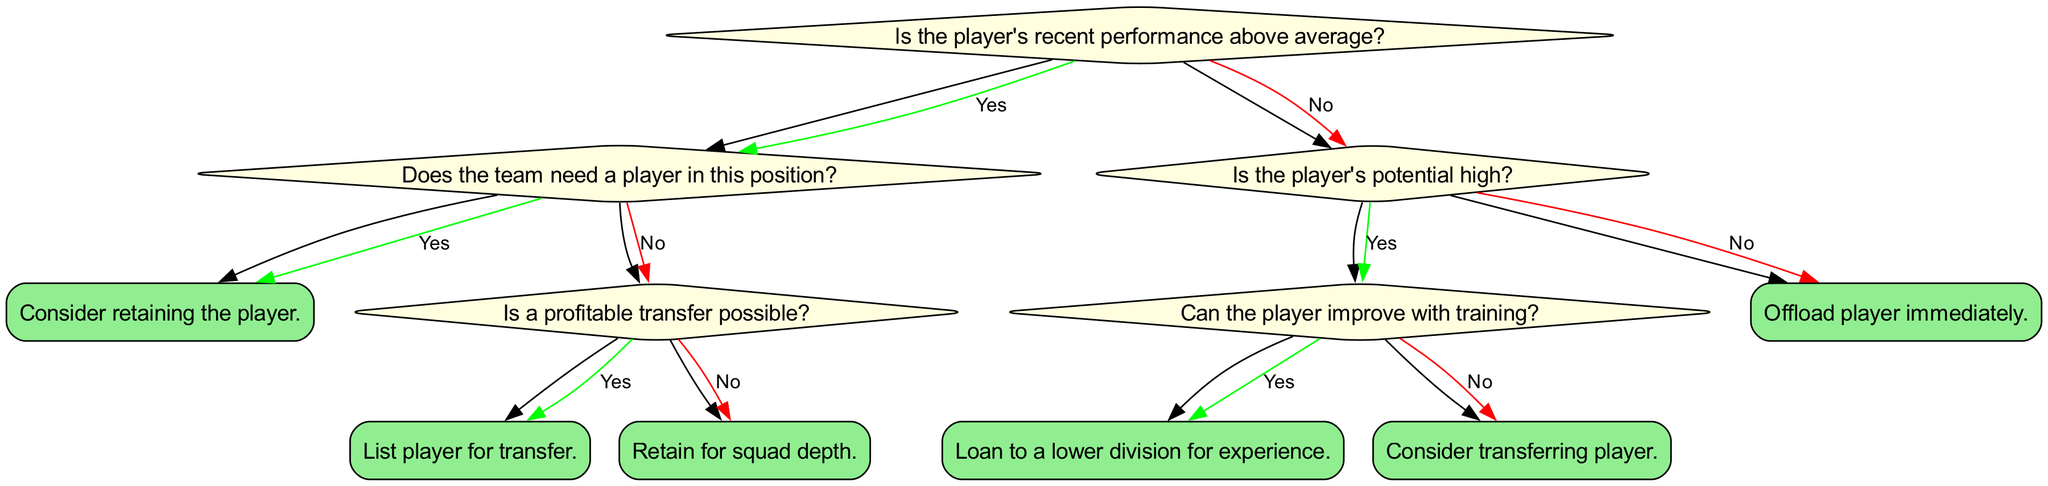Is the player's recent performance above average? The root question of the decision tree asks if the player's recent performance is above average. This is the first decision point that influences the subsequent questions and actions that can be taken regarding the player.
Answer: Yes What action is suggested if the team needs a player in this position? If the answer to the previous question is yes, and the team needs a player in this position, the action to take is to consider retaining the player. This reflects the team's commitment to keeping high-performing players where needed.
Answer: Consider retaining the player Is a profitable transfer possible if the team's need is absent? Following the path where the player's performance is above average but the team doesn't need a player in this position, we then evaluate whether a profitable transfer is possible. The answer to this question determines whether the player gets listed for transfer or retained for squad depth.
Answer: Yes What happens if the player's potential is assessed as high? If the player's recent performance is below average, the tree directs us to appraise the player's potential. If the potential is considered high, we then explore whether the player can improve with training, leading to further decision-making based on training potential.
Answer: Yes What action is taken if a player has low potential and performance? At the final decision point, if the player's performance is below average and is assessed as having low potential, the immediate action suggested is to offload the player without further evaluation or attempts to retain them.
Answer: Offload player immediately What is the action if the player can improve but doesn't have high potential? Following the evaluation of potential after determining that performance is below average, if the player can't improve with training, the logical step is to consider transferring the player, focused on finding a new club.
Answer: Consider transferring player 